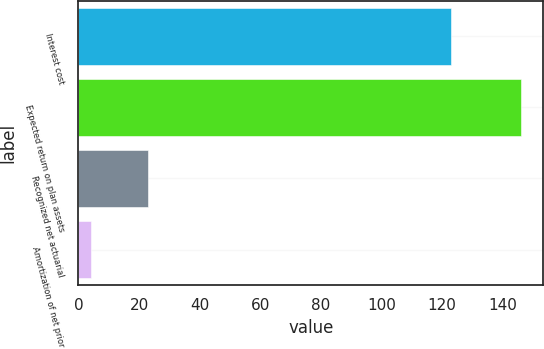Convert chart. <chart><loc_0><loc_0><loc_500><loc_500><bar_chart><fcel>Interest cost<fcel>Expected return on plan assets<fcel>Recognized net actuarial<fcel>Amortization of net prior<nl><fcel>123<fcel>146<fcel>23<fcel>4<nl></chart> 